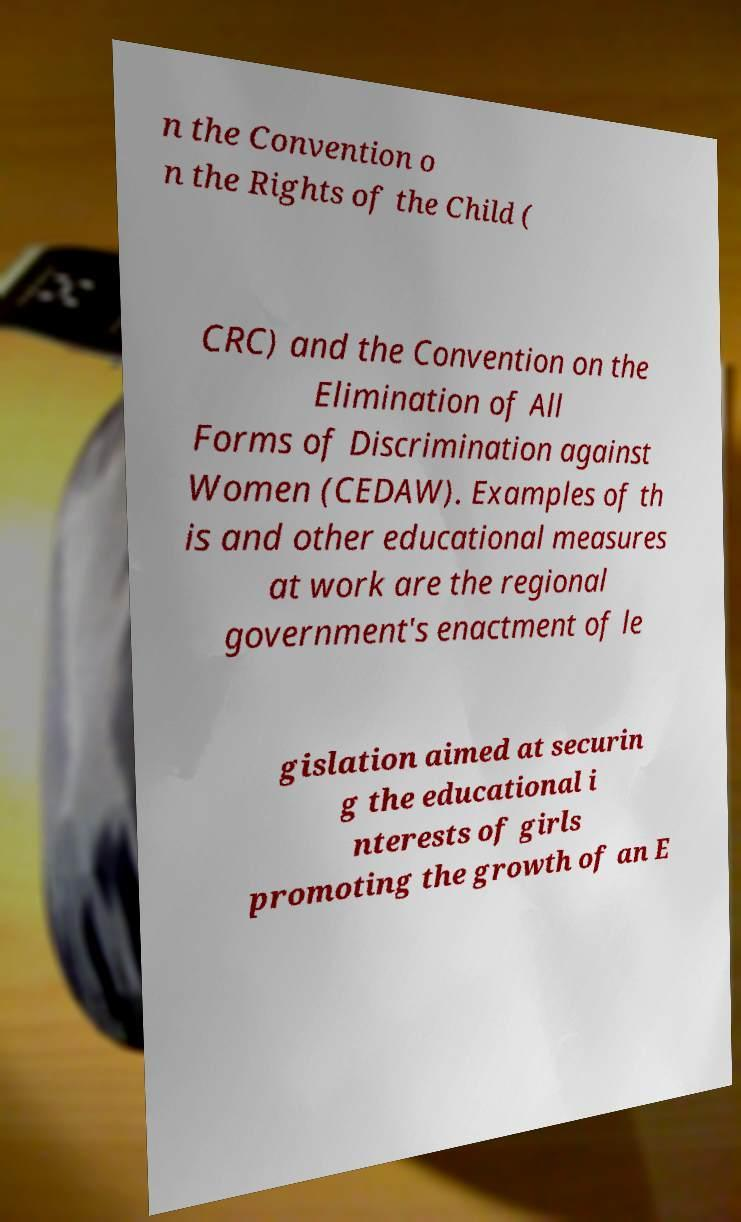Can you read and provide the text displayed in the image?This photo seems to have some interesting text. Can you extract and type it out for me? n the Convention o n the Rights of the Child ( CRC) and the Convention on the Elimination of All Forms of Discrimination against Women (CEDAW). Examples of th is and other educational measures at work are the regional government's enactment of le gislation aimed at securin g the educational i nterests of girls promoting the growth of an E 